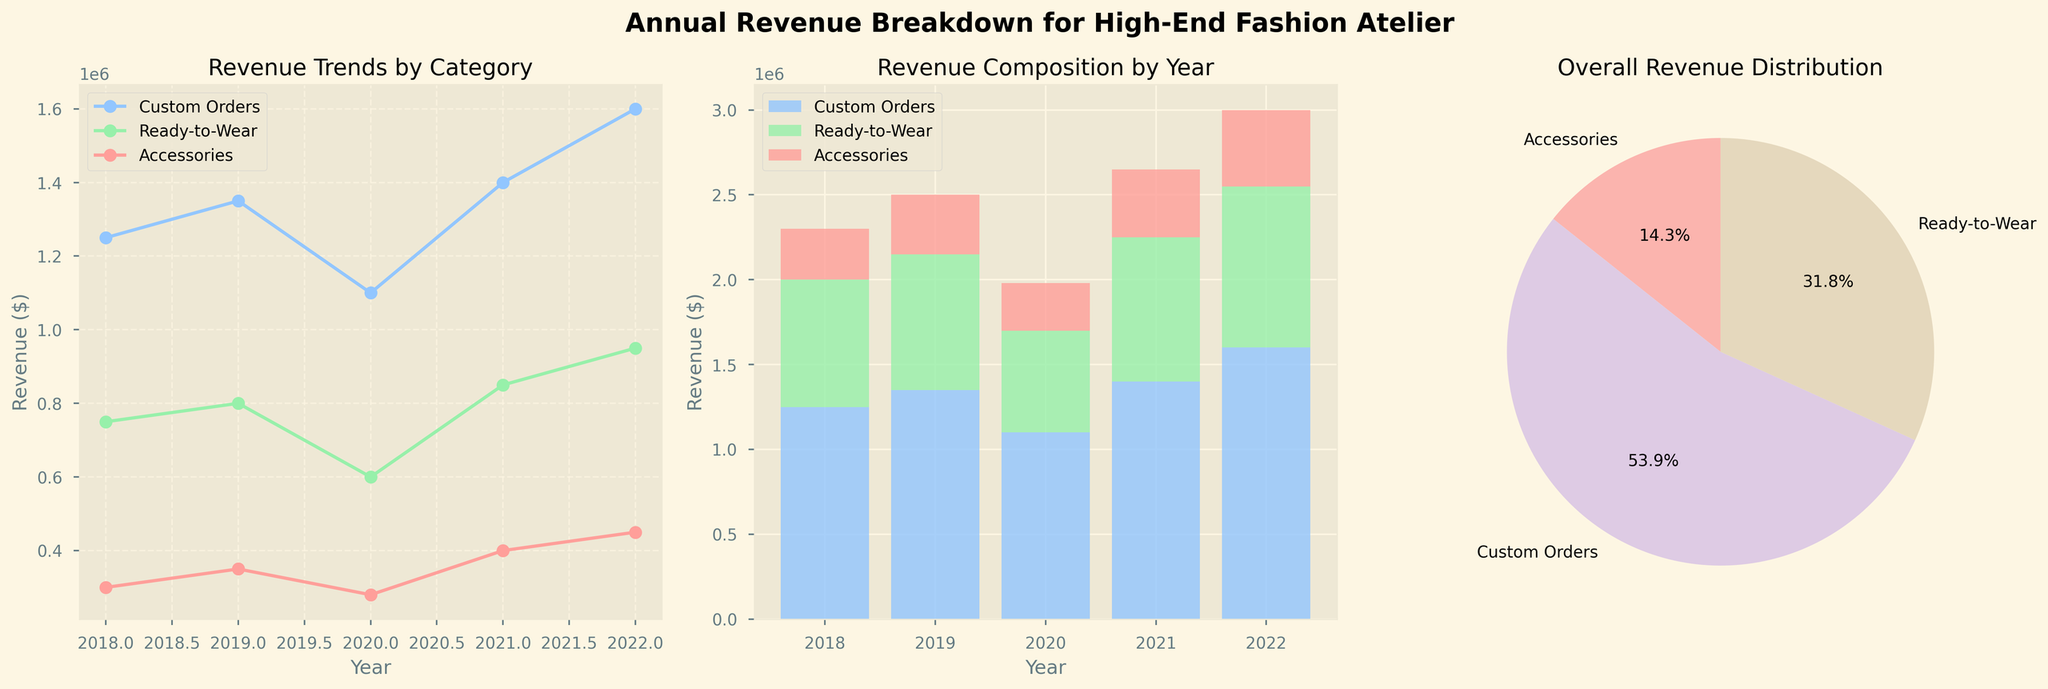What is the title of the figure? The title is given at the top of the entire figure. It reads "Annual Revenue Breakdown for High-End Fashion Atelier".
Answer: Annual Revenue Breakdown for High-End Fashion Atelier How many categories are shown in the overall revenue distribution pie chart? The pie chart labels show the names of each category, which are Custom Orders, Ready-to-Wear, and Accessories.
Answer: 3 Which year had the highest revenue for Custom Orders? In the line plot titled "Revenue Trends by Category", the line for Custom Orders reaches its highest point in the year 2022.
Answer: 2022 In the stacked bar plot, what is the revenue from Accessories in 2022? In the stacked bar plot titled "Revenue Composition by Year", the portion of the bar for Accessories in 2022 reaches 450,000 on the y-axis.
Answer: 450000 What is the total revenue in 2020? The stacked bar plot shows three stacked segments for 2020: Custom Orders (1,100,000), Ready-to-Wear (600,000), and Accessories (280,000). Summing these values gives the total revenue. 1,100,000 + 600,000 + 280,000 = 1,980,000.
Answer: 1980000 Is the revenue trend for Ready-to-Wear increasing or decreasing from 2018 to 2022? From the line plot, the line for Ready-to-Wear shows general upward movement from 2018 (750,000) to 2022 (950,000).
Answer: Increasing Which category has the smallest total revenue contribution according to the pie chart? In the pie chart, the smallest slice appears to be the one labeled “Accessories”.
Answer: Accessories What was the difference in revenue from Custom Orders between 2019 and 2020? The line plot shows 1,350,000 for 2019 and 1,100,000 for 2020 for Custom Orders. The difference is 1,350,000 - 1,100,000 = 250,000.
Answer: 250000 Which category had the largest growth in revenue from 2021 to 2022? From the line plot, Custom Orders show an increase from 1,400,000 in 2021 to 1,600,000 in 2022, which is the largest increase of 200,000 among the categories.
Answer: Custom Orders What percentage of the total revenue does the Ready-to-Wear category contribute according to the pie chart? In the pie chart, the slice for Ready-to-Wear is labeled with a percentage.
Answer: The exact percentage (need to see the figure to answer precisely, typically around 35-40%) 